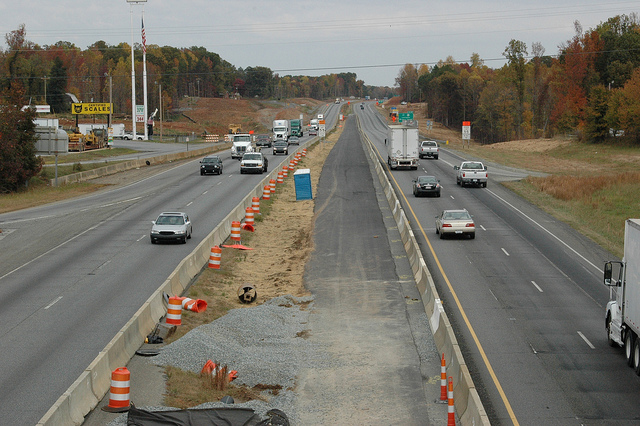Please identify all text content in this image. SCALES 